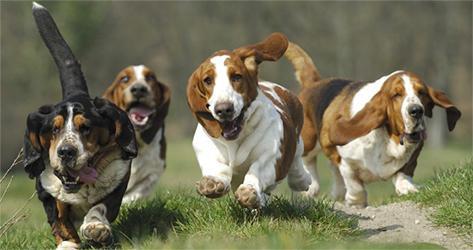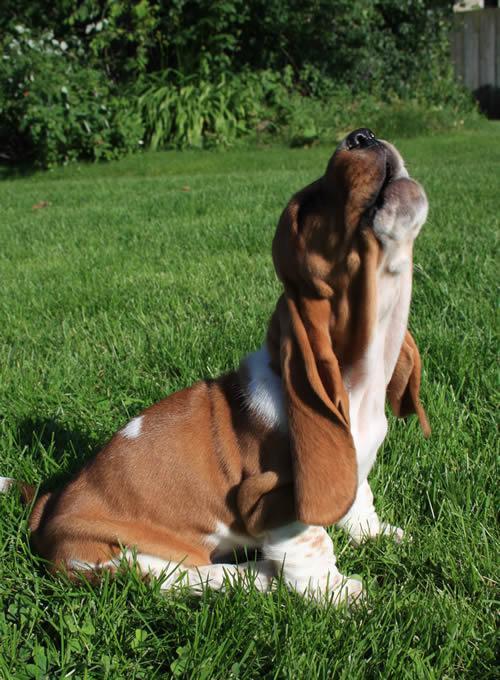The first image is the image on the left, the second image is the image on the right. Evaluate the accuracy of this statement regarding the images: "An image contains exactly one basset hound, which has tan and white coloring.". Is it true? Answer yes or no. Yes. The first image is the image on the left, the second image is the image on the right. Assess this claim about the two images: "There are at least two dogs sitting in the image on the left.". Correct or not? Answer yes or no. No. 